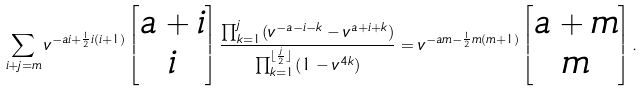Convert formula to latex. <formula><loc_0><loc_0><loc_500><loc_500>\sum _ { i + j = m } v ^ { - a i + \frac { 1 } { 2 } i ( i + 1 ) } \begin{bmatrix} a + i \\ i \end{bmatrix} \frac { \prod _ { k = 1 } ^ { j } ( v ^ { - a - i - k } - v ^ { a + i + k } ) } { \prod _ { k = 1 } ^ { \lfloor \frac { j } 2 \rfloor } ( 1 - v ^ { 4 k } ) } = v ^ { - a m - \frac { 1 } { 2 } m ( m + 1 ) } \begin{bmatrix} a + m \\ m \end{bmatrix} .</formula> 